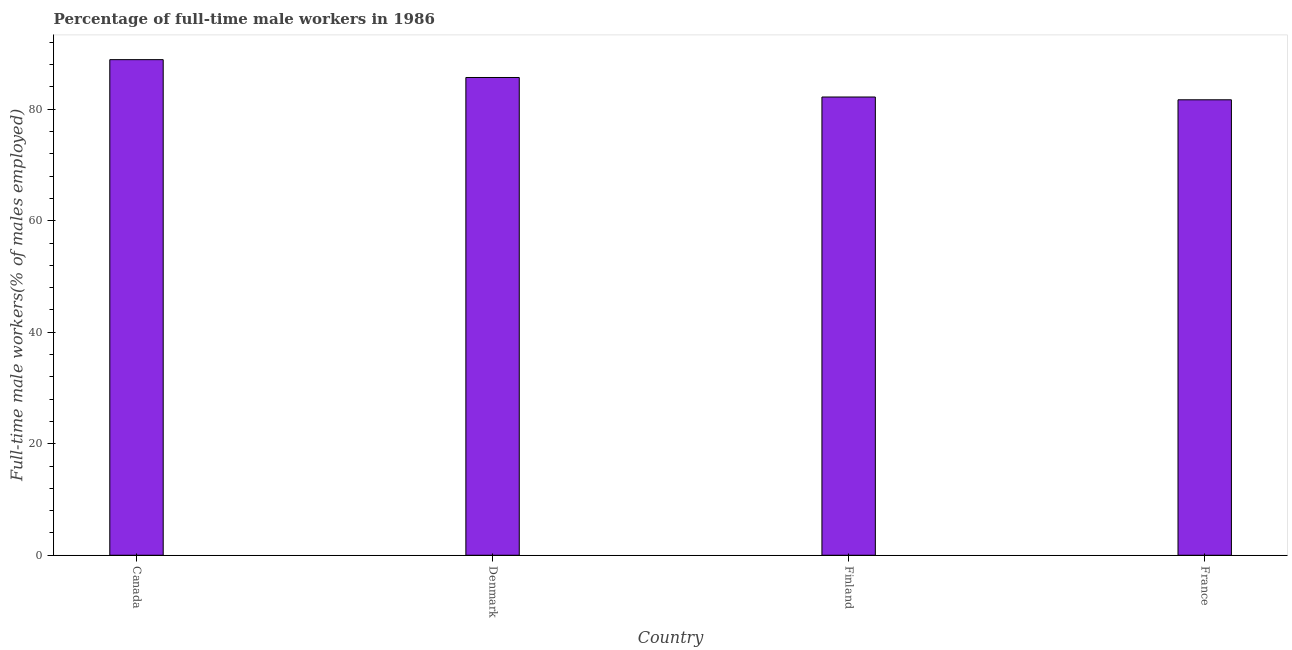What is the title of the graph?
Provide a short and direct response. Percentage of full-time male workers in 1986. What is the label or title of the X-axis?
Offer a very short reply. Country. What is the label or title of the Y-axis?
Your answer should be very brief. Full-time male workers(% of males employed). What is the percentage of full-time male workers in Denmark?
Your answer should be very brief. 85.7. Across all countries, what is the maximum percentage of full-time male workers?
Provide a short and direct response. 88.9. Across all countries, what is the minimum percentage of full-time male workers?
Keep it short and to the point. 81.7. In which country was the percentage of full-time male workers minimum?
Offer a terse response. France. What is the sum of the percentage of full-time male workers?
Offer a terse response. 338.5. What is the average percentage of full-time male workers per country?
Make the answer very short. 84.62. What is the median percentage of full-time male workers?
Provide a short and direct response. 83.95. In how many countries, is the percentage of full-time male workers greater than 20 %?
Your answer should be compact. 4. Is the percentage of full-time male workers in Canada less than that in Denmark?
Give a very brief answer. No. Is the difference between the percentage of full-time male workers in Finland and France greater than the difference between any two countries?
Provide a succinct answer. No. What is the difference between the highest and the second highest percentage of full-time male workers?
Make the answer very short. 3.2. Is the sum of the percentage of full-time male workers in Canada and France greater than the maximum percentage of full-time male workers across all countries?
Make the answer very short. Yes. What is the difference between the highest and the lowest percentage of full-time male workers?
Offer a terse response. 7.2. In how many countries, is the percentage of full-time male workers greater than the average percentage of full-time male workers taken over all countries?
Ensure brevity in your answer.  2. How many bars are there?
Ensure brevity in your answer.  4. Are all the bars in the graph horizontal?
Make the answer very short. No. How many countries are there in the graph?
Ensure brevity in your answer.  4. What is the difference between two consecutive major ticks on the Y-axis?
Ensure brevity in your answer.  20. What is the Full-time male workers(% of males employed) in Canada?
Make the answer very short. 88.9. What is the Full-time male workers(% of males employed) in Denmark?
Provide a succinct answer. 85.7. What is the Full-time male workers(% of males employed) of Finland?
Your response must be concise. 82.2. What is the Full-time male workers(% of males employed) in France?
Your response must be concise. 81.7. What is the difference between the Full-time male workers(% of males employed) in Finland and France?
Your response must be concise. 0.5. What is the ratio of the Full-time male workers(% of males employed) in Canada to that in Finland?
Give a very brief answer. 1.08. What is the ratio of the Full-time male workers(% of males employed) in Canada to that in France?
Your response must be concise. 1.09. What is the ratio of the Full-time male workers(% of males employed) in Denmark to that in Finland?
Make the answer very short. 1.04. What is the ratio of the Full-time male workers(% of males employed) in Denmark to that in France?
Give a very brief answer. 1.05. 